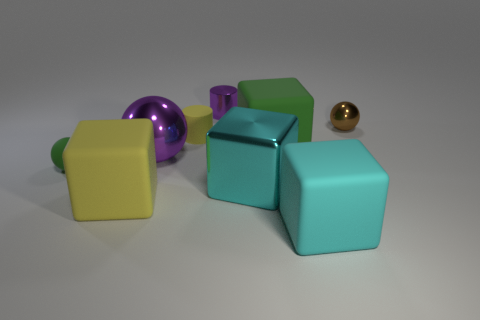Subtract 2 cubes. How many cubes are left? 2 Add 1 small brown cylinders. How many objects exist? 10 Subtract all blocks. How many objects are left? 5 Add 6 big gray metallic blocks. How many big gray metallic blocks exist? 6 Subtract 0 gray blocks. How many objects are left? 9 Subtract all cyan matte blocks. Subtract all small metallic things. How many objects are left? 6 Add 3 yellow matte cylinders. How many yellow matte cylinders are left? 4 